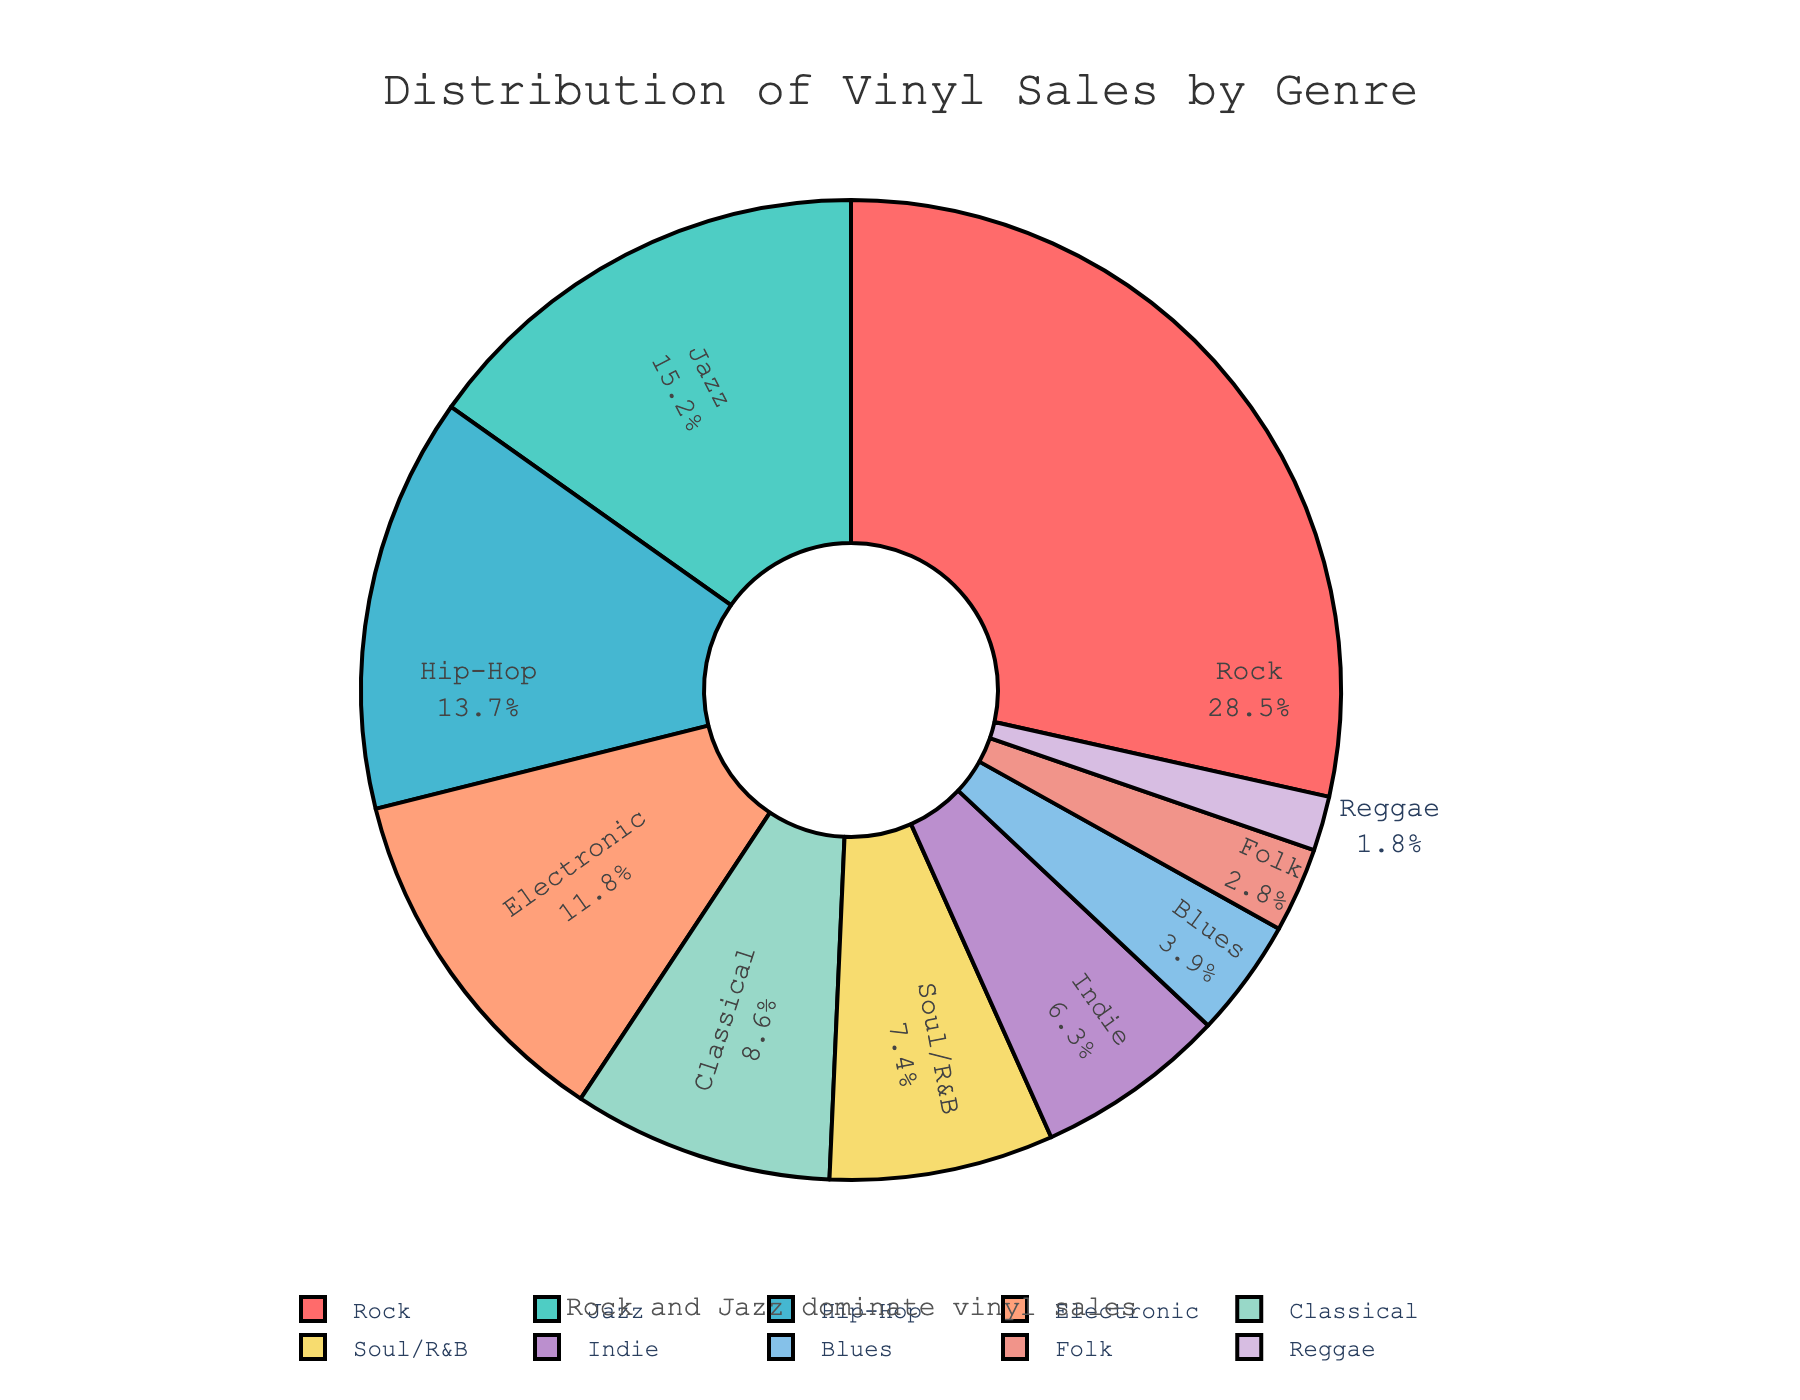What's the largest genre by vinyl sales? The figure shows different genres of vinyl sales by percentage, with the largest section labeled 'Rock' at 28.5%.
Answer: Rock Which genre has a higher percentage of vinyl sales: Jazz or Hip-Hop? By comparing the percentages in the figure, Jazz has 15.2% and Hip-Hop has 13.7%. Jazz has a higher percentage.
Answer: Jazz What is the combined percentage of vinyl sales for Classical and Soul/R&B genres? Classical has 8.6% and Soul/R&B has 7.4%. Adding these together: 8.6% + 7.4% = 16%.
Answer: 16% Is Indie more popular than Blues in terms of vinyl sales? By comparing the percentages, Indie has 6.3% and Blues has 3.9%. Indie is more popular.
Answer: Yes What is the difference in vinyl sales percentage between the top (Rock) and bottom (Reggae) genres? Rock has 28.5% and Reggae has 1.8%. The difference is 28.5% - 1.8% = 26.7%.
Answer: 26.7% How do the sales of Electronic music compare visually to that of Folk music? The pie chart shows a larger section for Electronic music (11.8%) compared to Folk music (2.8%). Visually, Electronic takes up a much larger portion.
Answer: Larger How many genres have a vinyl sales percentage less than 10%? The figure includes Jazz, Hip-Hop, Electronic, Classical, Soul/R&B, Indie, Blues, Folk, and Reggae. Counting those less than 10%: Classical, Soul/R&B, Indie, Blues, Folk, Reggae. That's 6 genres.
Answer: 6 Which two genres combined have almost the same vinyl sales percentage as Rock? Combining Jazz (15.2%) and Hip-Hop (13.7%) gives 15.2% + 13.7% = 28.9%, which is very close to Rock's 28.5%.
Answer: Jazz and Hip-Hop Does the annotation in the chart agree with the actual data distribution? The annotation mentions "Rock and Jazz dominate vinyl sales," which is accurate as Rock (28.5%) is highest and Jazz (15.2%) is second-highest.
Answer: Yes 